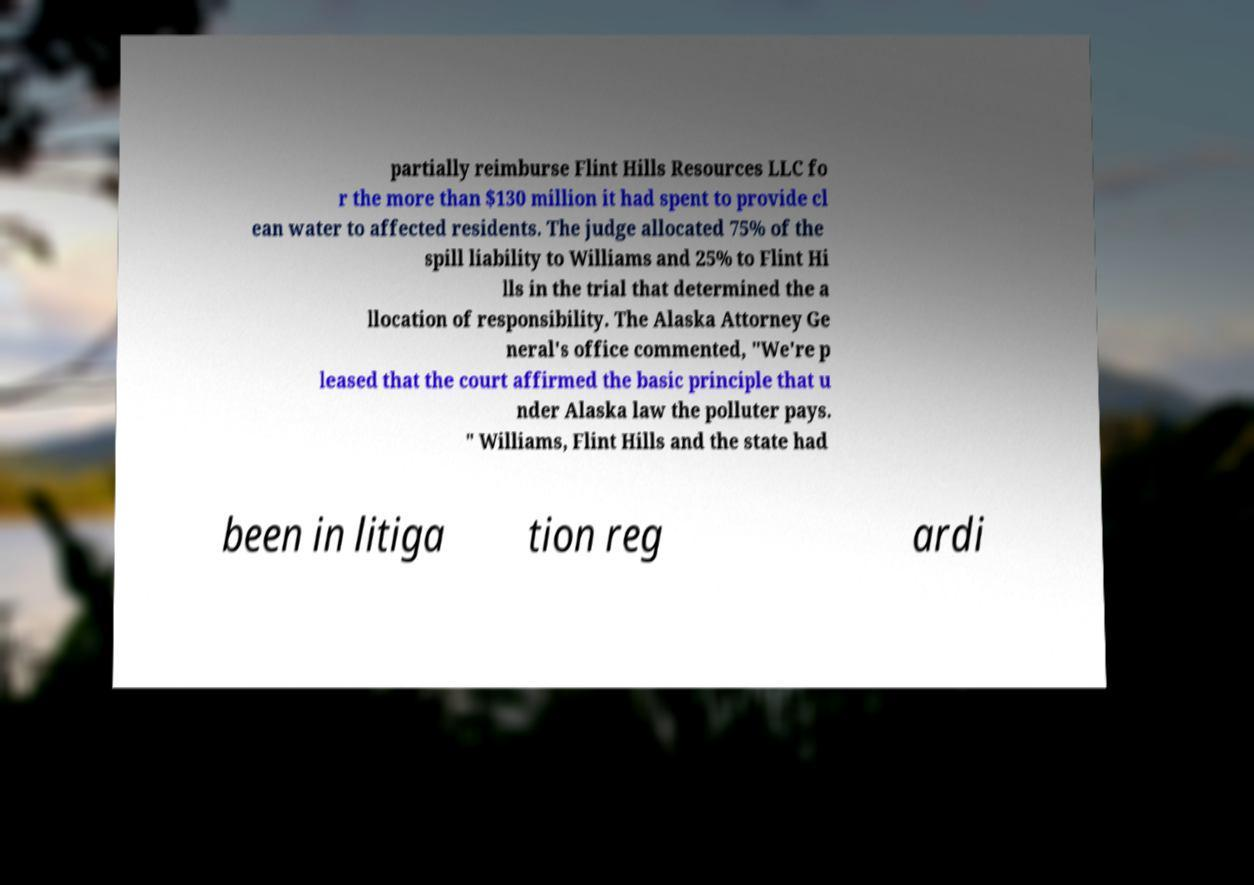Could you assist in decoding the text presented in this image and type it out clearly? partially reimburse Flint Hills Resources LLC fo r the more than $130 million it had spent to provide cl ean water to affected residents. The judge allocated 75% of the spill liability to Williams and 25% to Flint Hi lls in the trial that determined the a llocation of responsibility. The Alaska Attorney Ge neral's office commented, "We're p leased that the court affirmed the basic principle that u nder Alaska law the polluter pays. " Williams, Flint Hills and the state had been in litiga tion reg ardi 